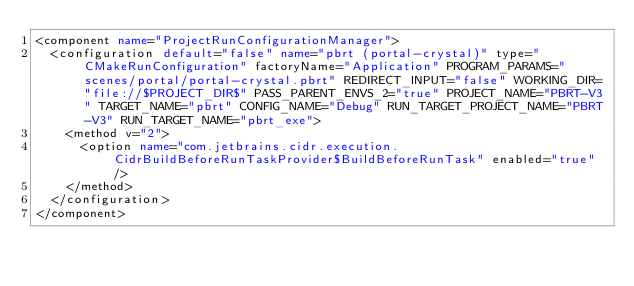<code> <loc_0><loc_0><loc_500><loc_500><_XML_><component name="ProjectRunConfigurationManager">
  <configuration default="false" name="pbrt (portal-crystal)" type="CMakeRunConfiguration" factoryName="Application" PROGRAM_PARAMS="scenes/portal/portal-crystal.pbrt" REDIRECT_INPUT="false" WORKING_DIR="file://$PROJECT_DIR$" PASS_PARENT_ENVS_2="true" PROJECT_NAME="PBRT-V3" TARGET_NAME="pbrt" CONFIG_NAME="Debug" RUN_TARGET_PROJECT_NAME="PBRT-V3" RUN_TARGET_NAME="pbrt_exe">
    <method v="2">
      <option name="com.jetbrains.cidr.execution.CidrBuildBeforeRunTaskProvider$BuildBeforeRunTask" enabled="true" />
    </method>
  </configuration>
</component></code> 